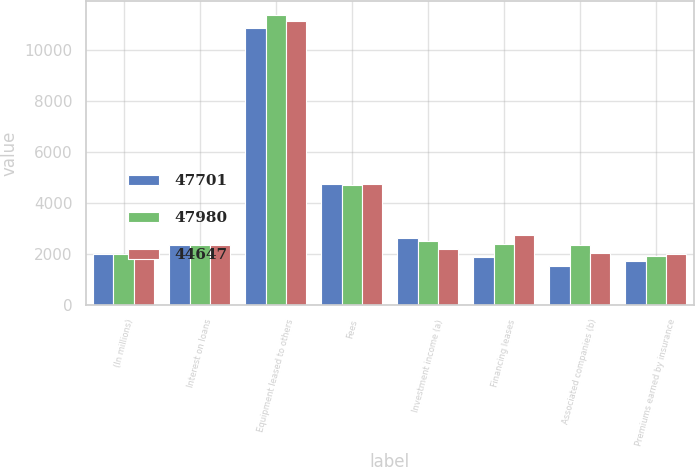Convert chart. <chart><loc_0><loc_0><loc_500><loc_500><stacked_bar_chart><ecel><fcel>(In millions)<fcel>Interest on loans<fcel>Equipment leased to others<fcel>Fees<fcel>Investment income (a)<fcel>Financing leases<fcel>Associated companies (b)<fcel>Premiums earned by insurance<nl><fcel>47701<fcel>2012<fcel>2337<fcel>10855<fcel>4732<fcel>2630<fcel>1888<fcel>1538<fcel>1714<nl><fcel>47980<fcel>2011<fcel>2337<fcel>11343<fcel>4698<fcel>2500<fcel>2378<fcel>2337<fcel>1905<nl><fcel>44647<fcel>2010<fcel>2337<fcel>11116<fcel>4734<fcel>2185<fcel>2749<fcel>2035<fcel>2014<nl></chart> 